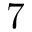<formula> <loc_0><loc_0><loc_500><loc_500>7</formula> 